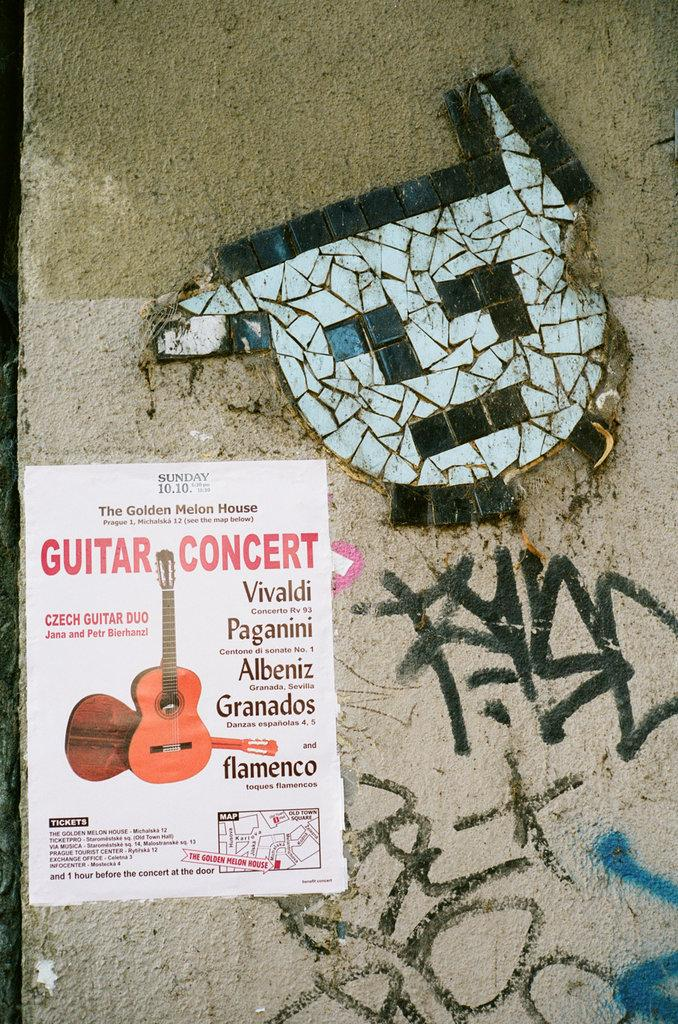<image>
Describe the image concisely. A flyer with a guitar concert written on a poster with a white design on top. 